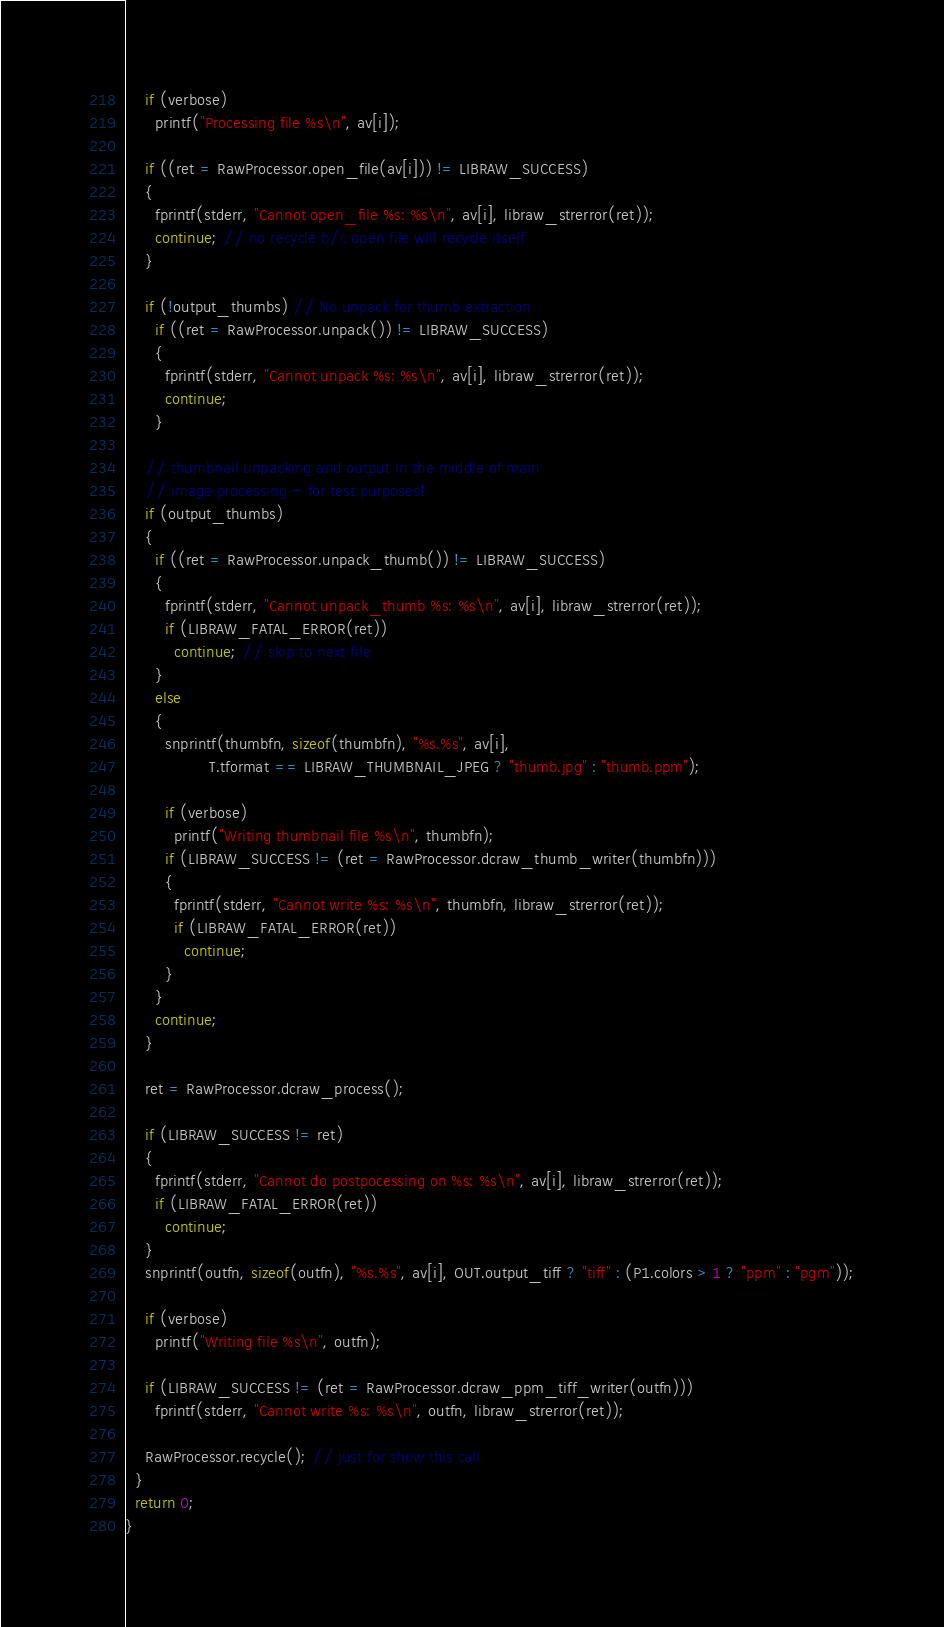<code> <loc_0><loc_0><loc_500><loc_500><_C++_>    if (verbose)
      printf("Processing file %s\n", av[i]);

    if ((ret = RawProcessor.open_file(av[i])) != LIBRAW_SUCCESS)
    {
      fprintf(stderr, "Cannot open_file %s: %s\n", av[i], libraw_strerror(ret));
      continue; // no recycle b/c open file will recycle itself
    }

    if (!output_thumbs) // No unpack for thumb extraction
      if ((ret = RawProcessor.unpack()) != LIBRAW_SUCCESS)
      {
        fprintf(stderr, "Cannot unpack %s: %s\n", av[i], libraw_strerror(ret));
        continue;
      }

    // thumbnail unpacking and output in the middle of main
    // image processing - for test purposes!
    if (output_thumbs)
    {
      if ((ret = RawProcessor.unpack_thumb()) != LIBRAW_SUCCESS)
      {
        fprintf(stderr, "Cannot unpack_thumb %s: %s\n", av[i], libraw_strerror(ret));
        if (LIBRAW_FATAL_ERROR(ret))
          continue; // skip to next file
      }
      else
      {
        snprintf(thumbfn, sizeof(thumbfn), "%s.%s", av[i],
                 T.tformat == LIBRAW_THUMBNAIL_JPEG ? "thumb.jpg" : "thumb.ppm");

        if (verbose)
          printf("Writing thumbnail file %s\n", thumbfn);
        if (LIBRAW_SUCCESS != (ret = RawProcessor.dcraw_thumb_writer(thumbfn)))
        {
          fprintf(stderr, "Cannot write %s: %s\n", thumbfn, libraw_strerror(ret));
          if (LIBRAW_FATAL_ERROR(ret))
            continue;
        }
      }
      continue;
    }

    ret = RawProcessor.dcraw_process();

    if (LIBRAW_SUCCESS != ret)
    {
      fprintf(stderr, "Cannot do postpocessing on %s: %s\n", av[i], libraw_strerror(ret));
      if (LIBRAW_FATAL_ERROR(ret))
        continue;
    }
    snprintf(outfn, sizeof(outfn), "%s.%s", av[i], OUT.output_tiff ? "tiff" : (P1.colors > 1 ? "ppm" : "pgm"));

    if (verbose)
      printf("Writing file %s\n", outfn);

    if (LIBRAW_SUCCESS != (ret = RawProcessor.dcraw_ppm_tiff_writer(outfn)))
      fprintf(stderr, "Cannot write %s: %s\n", outfn, libraw_strerror(ret));

    RawProcessor.recycle(); // just for show this call
  }
  return 0;
}
</code> 